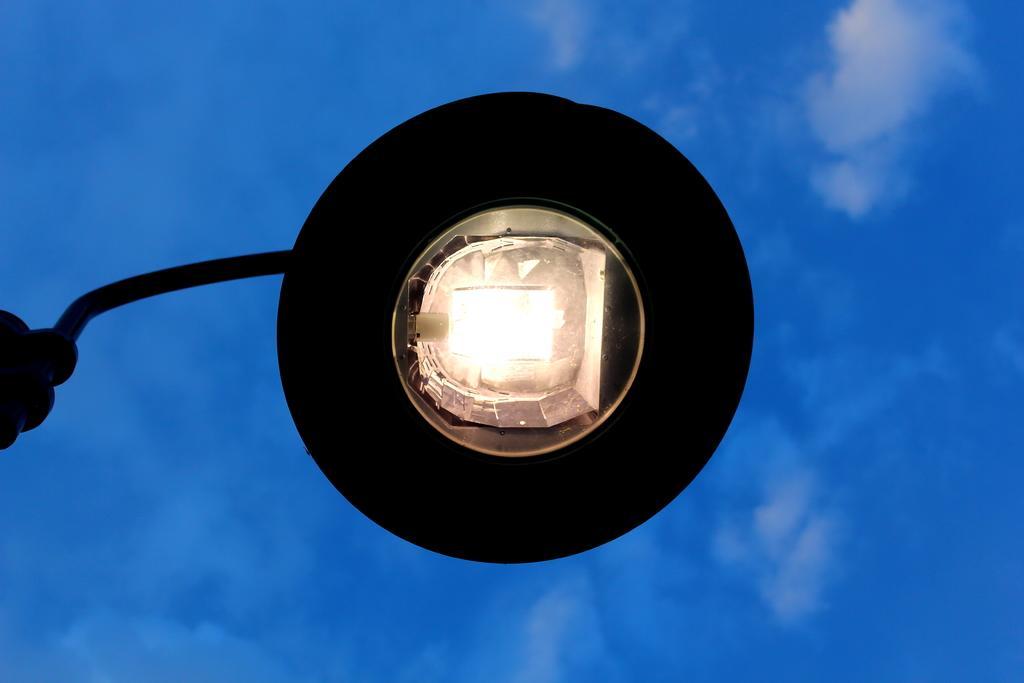In one or two sentences, can you explain what this image depicts? In this picture we can see a street light and a rod. Sky is blue in color and cloudy. 